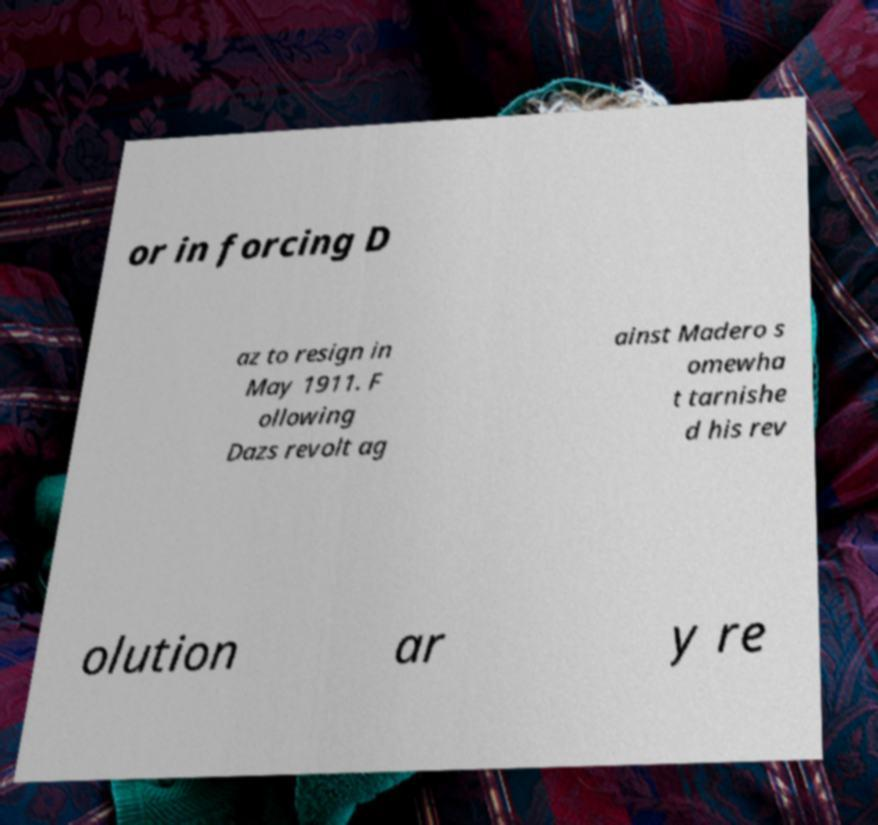Could you extract and type out the text from this image? or in forcing D az to resign in May 1911. F ollowing Dazs revolt ag ainst Madero s omewha t tarnishe d his rev olution ar y re 